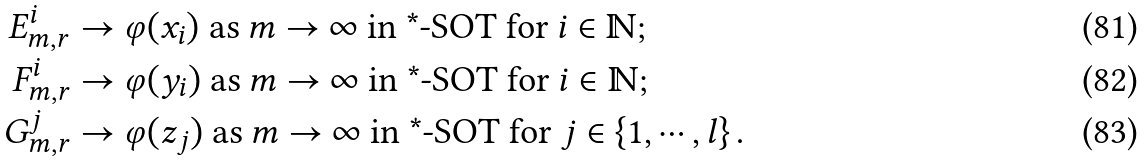<formula> <loc_0><loc_0><loc_500><loc_500>E _ { m , r } ^ { i } & \rightarrow \varphi ( x _ { i } ) \text { as } m \rightarrow \infty \text { in *-SOT for } i \in \mathbb { N } ; \\ F _ { m , r } ^ { i } & \rightarrow \varphi ( y _ { i } ) \text { as } m \rightarrow \infty \text { in *-SOT for } i \in \mathbb { N } ; \\ G _ { m , r } ^ { j } & \rightarrow \varphi ( z _ { j } ) \text { as } m \rightarrow \infty \text { in *-SOT for } j \in \left \{ 1 , \cdots , l \right \} .</formula> 